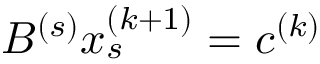Convert formula to latex. <formula><loc_0><loc_0><loc_500><loc_500>B ^ { ( s ) } x _ { s } ^ { ( k + 1 ) } = c ^ { ( k ) }</formula> 